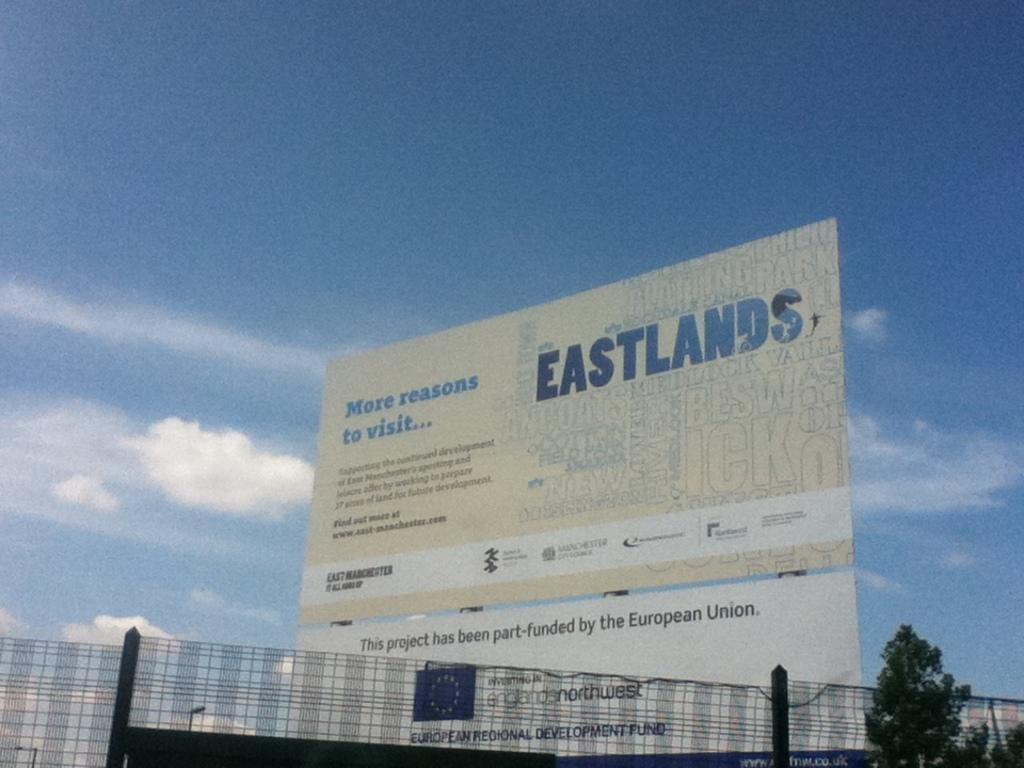Provide a one-sentence caption for the provided image. a banner that reads eastlands more reasons to visit. 